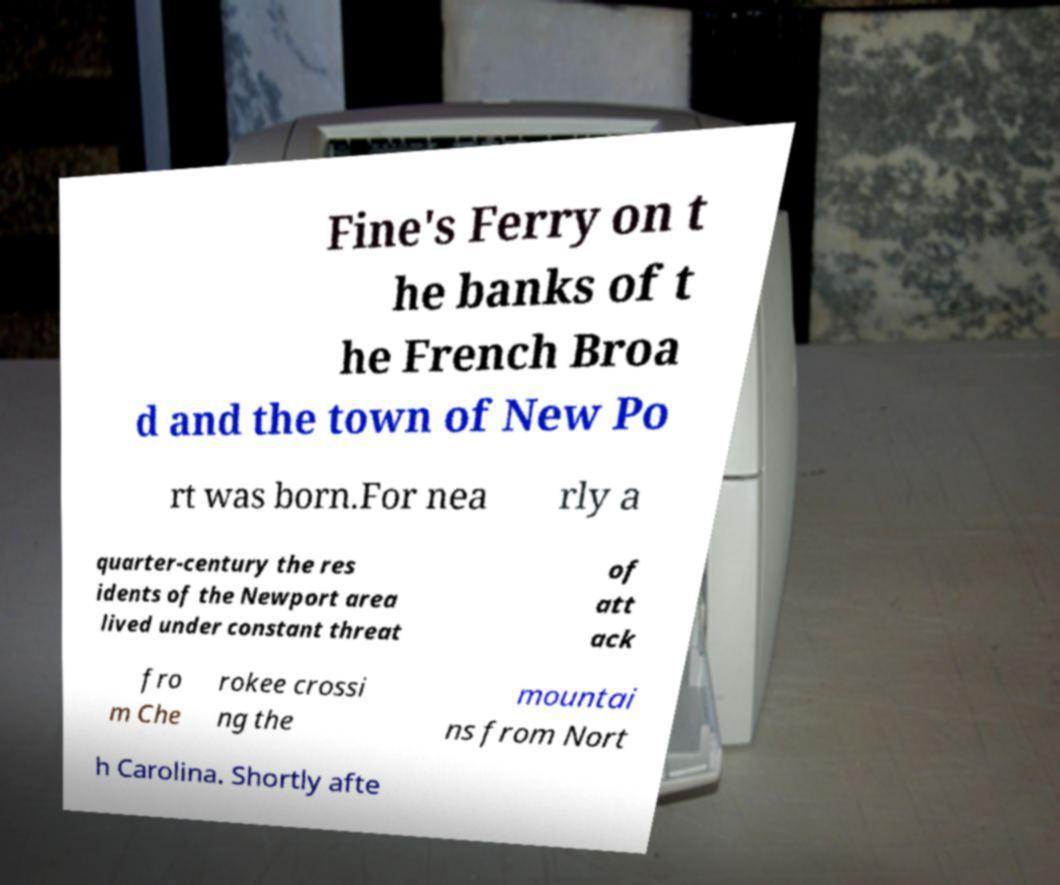There's text embedded in this image that I need extracted. Can you transcribe it verbatim? Fine's Ferry on t he banks of t he French Broa d and the town of New Po rt was born.For nea rly a quarter-century the res idents of the Newport area lived under constant threat of att ack fro m Che rokee crossi ng the mountai ns from Nort h Carolina. Shortly afte 